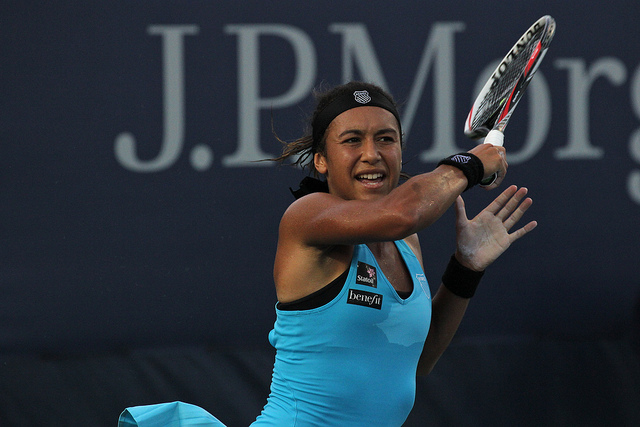Please identify all text content in this image. J.P.Mor benefit 